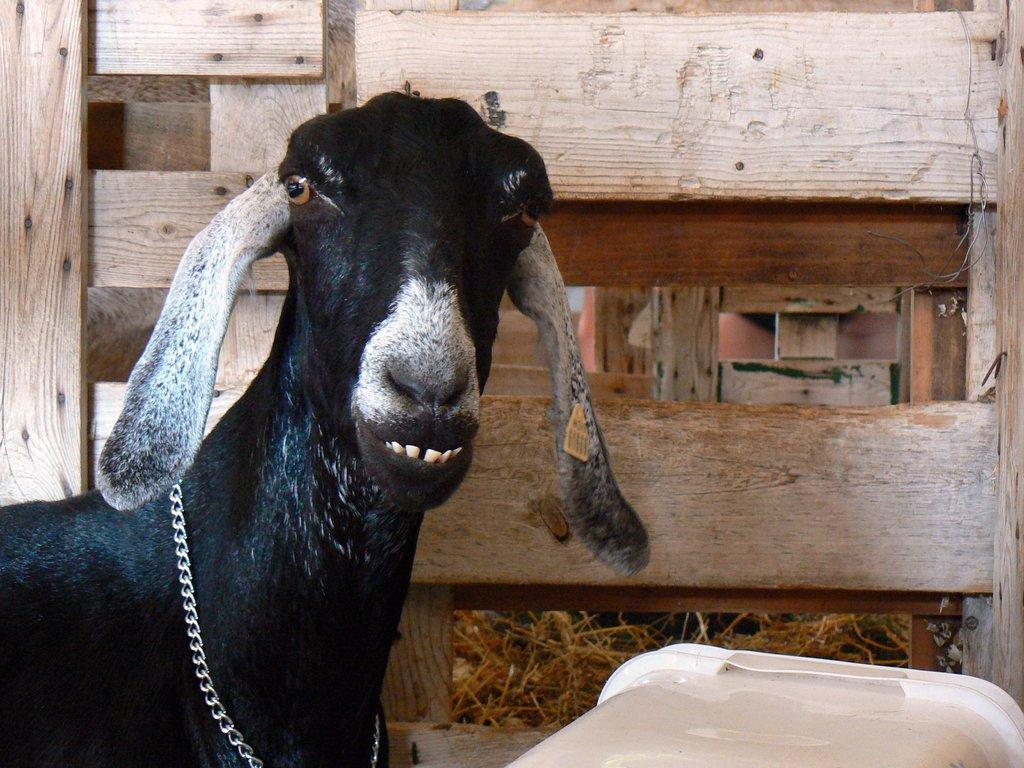What animal is located on the left side of the image? There is a goat on the left side of the image. What can be seen in the background of the image? There is a fence visible in the background of the image. What type of vegetation is present at the bottom of the image? Dry grass is present at the bottom of the image. What object is located at the bottom of the image? There is a container at the bottom of the image. What type of baby is being shown in the image? There is no baby present in the image; it features a goat, a fence, dry grass, and a container. 